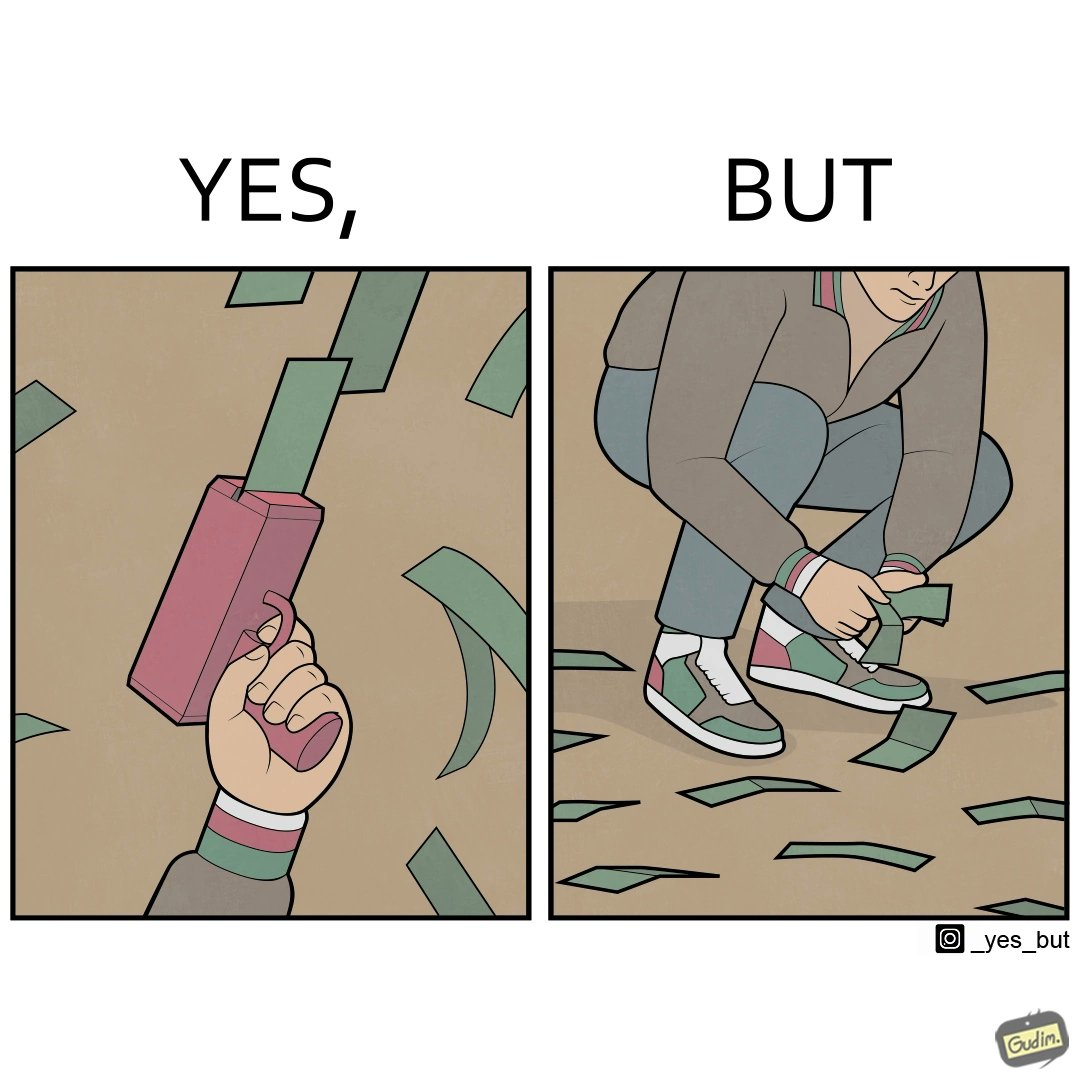What is the satirical meaning behind this image? The image is satirical because the man that is shooting money in the air causing a rain of money bills is the same person who is crouching down to collect the fallen dollar bills from the ground which makes the act of shooting bills in the air not so fun. 